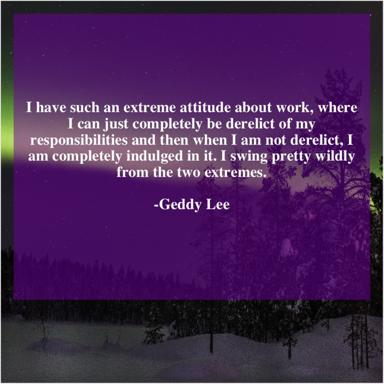What might be the implications of such an approach to work as described by Geddy Lee? Such an extreme approach to work could suggest a passionate, albeit potentially unstable work ethic that might lead to bursts of high productivity followed by periods of burnout. It highlights the challenges and potential mental strain associated with swinging widely between intense dedication and relative inactivity. How can someone manage such extremes in work habits effectively? Managing such extreme work habits could involve setting more structured schedules, prioritizing self-care to prevent burnout, and seeking a balanced approach that allows for both productivity and relaxation. Establishing clear boundaries and goals can also help in maintaining a more consistent commitment to work responsibilities. 